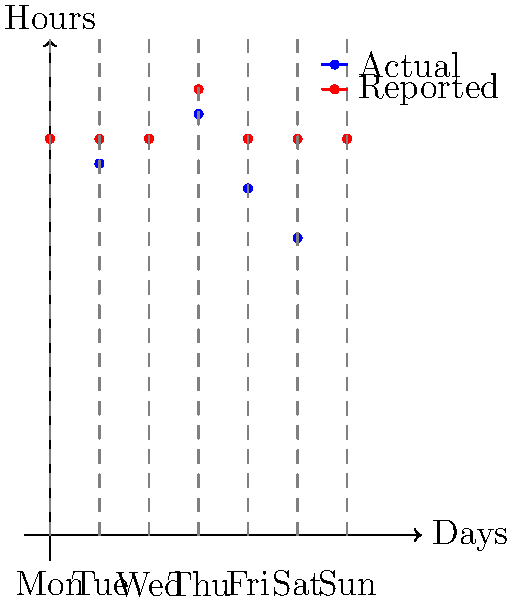As a small business owner, you've noticed discrepancies between reported hours and actual hours worked. The graph shows actual hours (blue) and reported hours (red) for a week. What is the total number of over-reported hours for the week? To find the total number of over-reported hours, we need to:

1. Calculate the difference between reported and actual hours for each day:
   Monday: $8 - 8 = 0$
   Tuesday: $8 - 7.5 = 0.5$
   Wednesday: $8 - 8 = 0$
   Thursday: $9 - 8.5 = 0.5$
   Friday: $8 - 7 = 1$
   Saturday: $8 - 6 = 2$
   Sunday: $8 - 8 = 0$

2. Sum up all the positive differences:
   $0 + 0.5 + 0 + 0.5 + 1 + 2 + 0 = 4$

Therefore, the total number of over-reported hours for the week is 4 hours.
Answer: 4 hours 